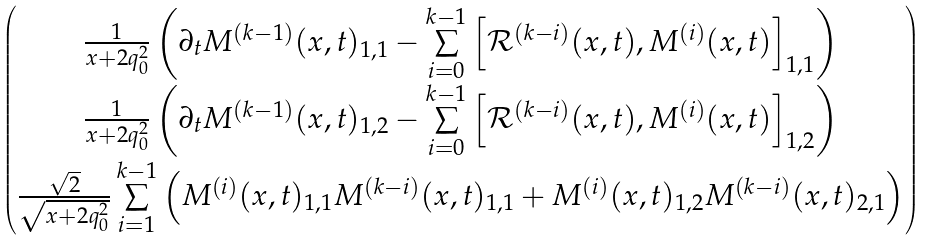<formula> <loc_0><loc_0><loc_500><loc_500>\begin{pmatrix} \frac { 1 } { x + 2 q _ { 0 } ^ { 2 } } \left ( \partial _ { t } M ^ { ( k - 1 ) } ( x , t ) _ { 1 , 1 } - \underset { i = 0 } { \overset { k - 1 } { \sum } } \left [ \mathcal { R } ^ { ( k - i ) } ( x , t ) , M ^ { ( i ) } ( x , t ) \right ] _ { 1 , 1 } \right ) \\ \frac { 1 } { x + 2 q _ { 0 } ^ { 2 } } \left ( \partial _ { t } M ^ { ( k - 1 ) } ( x , t ) _ { 1 , 2 } - \underset { i = 0 } { \overset { k - 1 } { \sum } } \left [ \mathcal { R } ^ { ( k - i ) } ( x , t ) , M ^ { ( i ) } ( x , t ) \right ] _ { 1 , 2 } \right ) \\ \frac { \sqrt { 2 } } { \sqrt { x + 2 q _ { 0 } ^ { 2 } } } \, \underset { i = 1 } { \overset { k - 1 } { \sum } } \left ( M ^ { ( i ) } ( x , t ) _ { 1 , 1 } M ^ { ( k - i ) } ( x , t ) _ { 1 , 1 } + M ^ { ( i ) } ( x , t ) _ { 1 , 2 } M ^ { ( k - i ) } ( x , t ) _ { 2 , 1 } \right ) \end{pmatrix}</formula> 